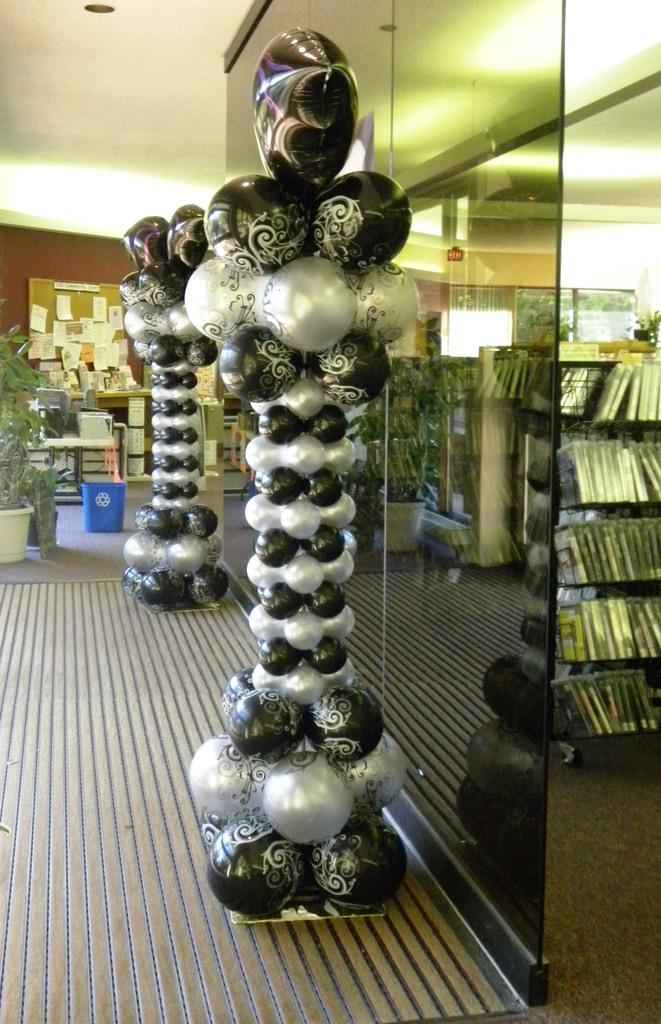What type of decoration is present in the image? There is a balloon arch with a stand in the image. What type of architectural feature can be seen in the image? There is a glass wall in the image. What can be found on the left side of the image? There is a plant pot on the left side of the image. What type of items are stored on a rack in the image? There are books on a rack in the image. What type of apparel is being sold at the zoo in the image? There is no mention of a zoo or apparel being sold in the image. The image features a balloon arch, a glass wall, a plant pot, and books on a rack. 